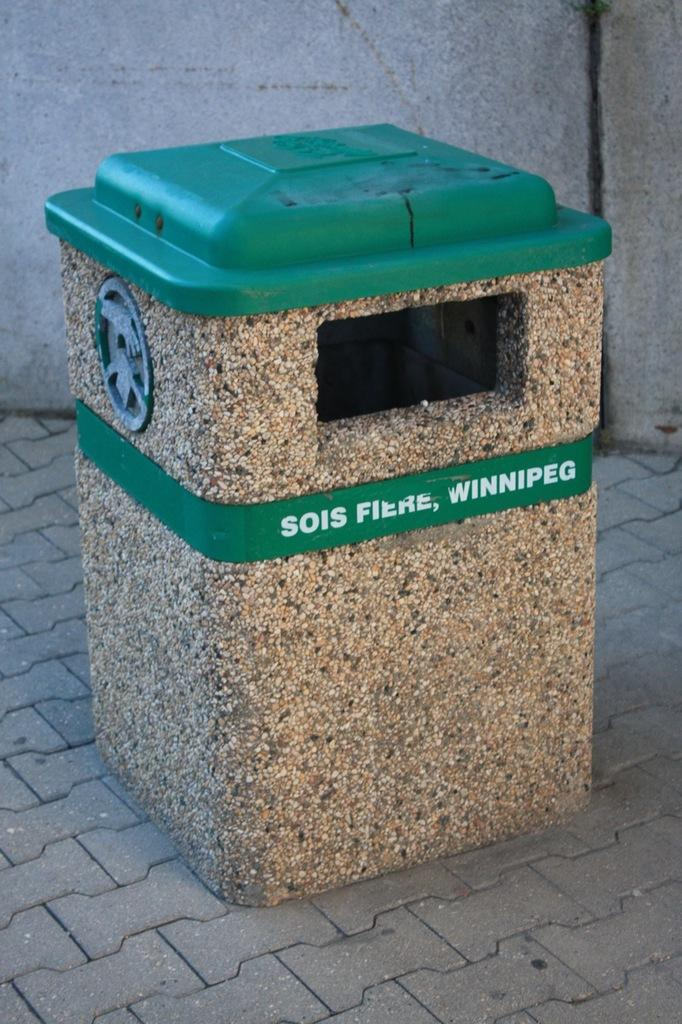<image>
Present a compact description of the photo's key features. A green topped trash can has the name winnipeg on its middle section. 